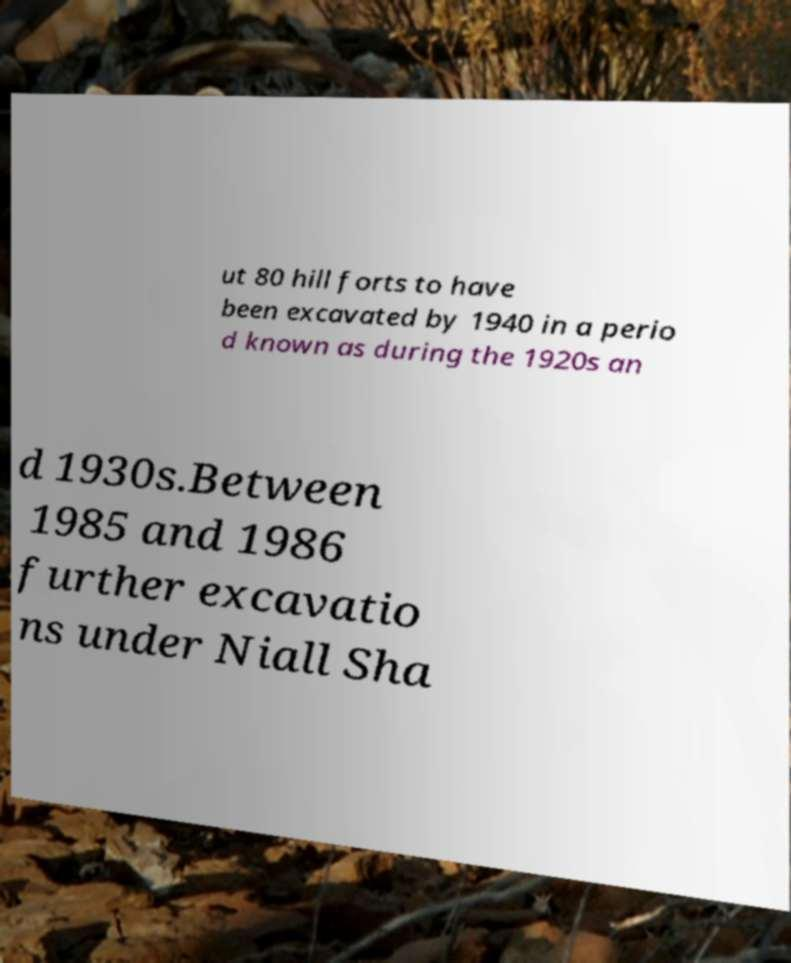Can you read and provide the text displayed in the image?This photo seems to have some interesting text. Can you extract and type it out for me? ut 80 hill forts to have been excavated by 1940 in a perio d known as during the 1920s an d 1930s.Between 1985 and 1986 further excavatio ns under Niall Sha 